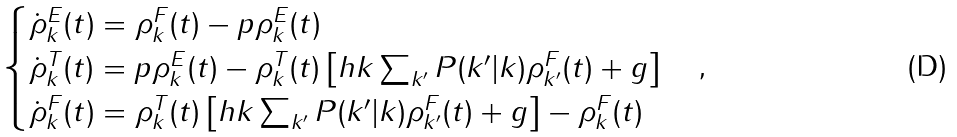<formula> <loc_0><loc_0><loc_500><loc_500>\begin{cases} \dot { \rho } ^ { E } _ { k } ( t ) = \rho ^ { F } _ { k } ( t ) - p \rho ^ { E } _ { k } ( t ) \\ \dot { \rho } ^ { T } _ { k } ( t ) = p \rho ^ { E } _ { k } ( t ) - \rho ^ { T } _ { k } ( t ) \left [ h k \sum _ { k ^ { \prime } } P ( k ^ { \prime } | k ) \rho ^ { F } _ { k ^ { \prime } } ( t ) + g \right ] \\ \dot { \rho } ^ { F } _ { k } ( t ) = \rho ^ { T } _ { k } ( t ) \left [ h k \sum _ { k ^ { \prime } } P ( k ^ { \prime } | k ) \rho ^ { F } _ { k ^ { \prime } } ( t ) + g \right ] - \rho ^ { F } _ { k } ( t ) \end{cases} ,</formula> 